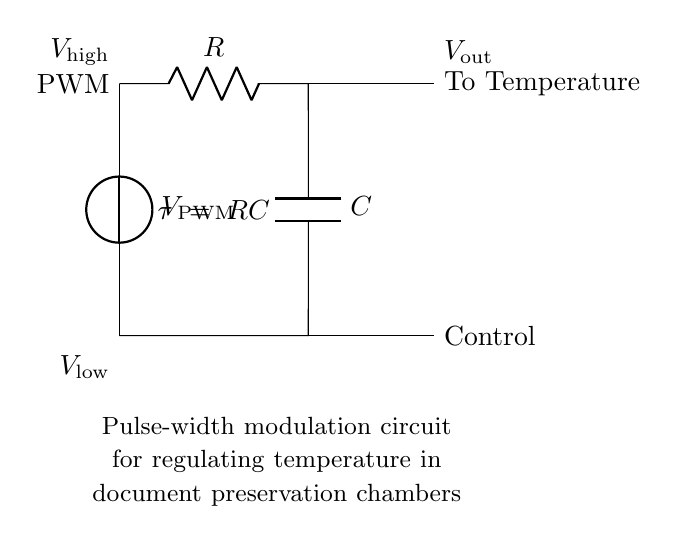What is the voltage of the PWM source? The PWM source voltage is represented as V_PWM in the circuit, indicating it is the input voltage driving the pulse-width modulation path.
Answer: V_PWM What component is used to filter the PWM signal? The circuit uses a resistor (R) and a capacitor (C) in series to form a low-pass filter. This combination smooths out the PWM signal to provide a steadier output voltage.
Answer: R and C What does V_out signify in this circuit? V_out represents the output voltage that results from the low-pass filtering of the PWM signal and is directed to the temperature control system for regulation.
Answer: V_out How is the output voltage derived from the PWM source? The output voltage (V_out) is obtained by passing the PWM voltage through the resistor-capacitor network, which averages the varying PWM input voltages, resulting in a smoother DC voltage suitable for temperature control applications.
Answer: By averaging PWM What is the time constant of this RC circuit? The time constant (τ) for the resistor-capacitor circuit is given by the product of resistance (R) and capacitance (C), which characterizes the response speed of the filter to changes in the PWM signal.
Answer: RC What is the purpose of the pulse-width modulation in this circuit? The purpose of pulse-width modulation is to control the amount of power delivered to the temperature control system by varying the duty cycle of the input signal, thus regulating the temperature effectively in document preservation chambers.
Answer: Temperature regulation 